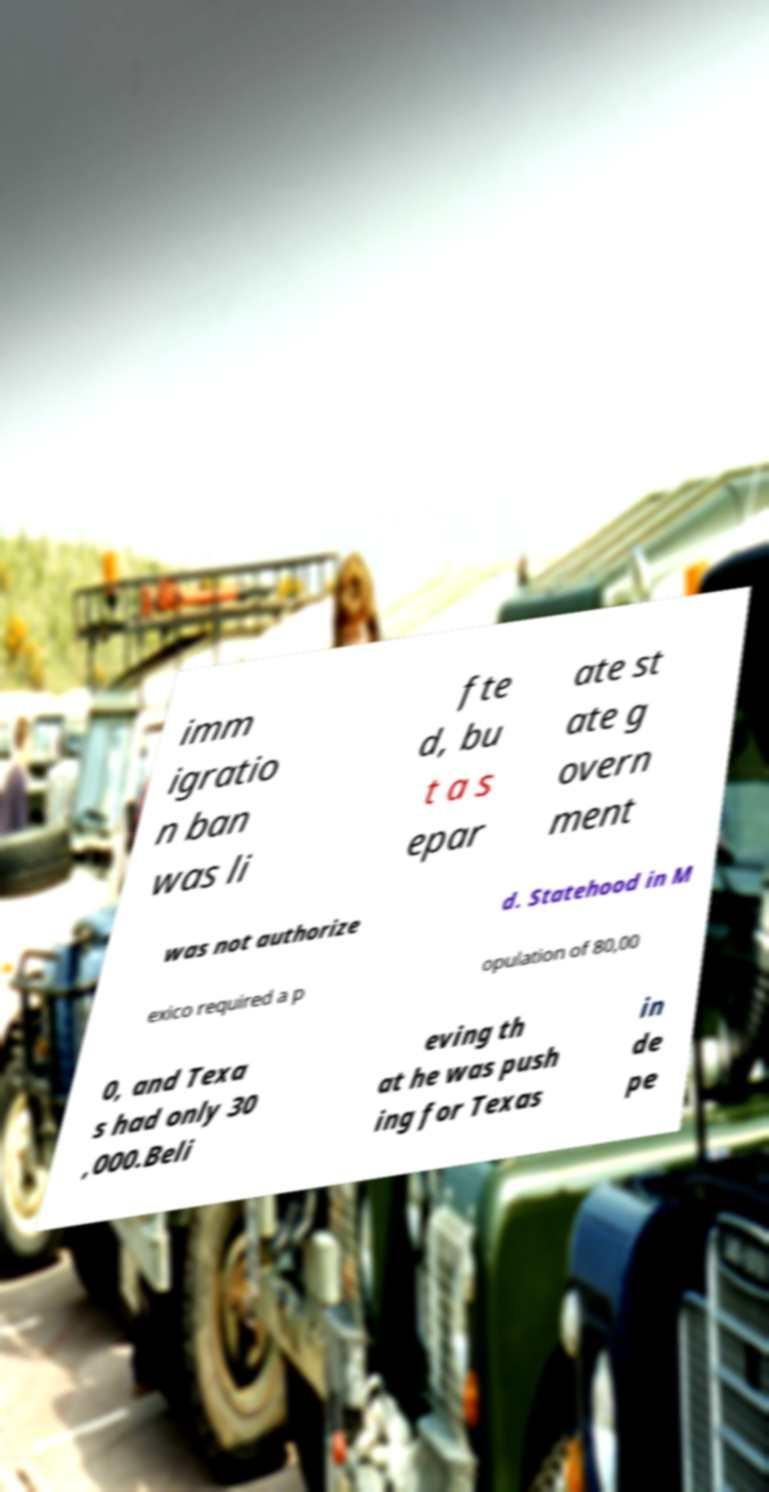There's text embedded in this image that I need extracted. Can you transcribe it verbatim? imm igratio n ban was li fte d, bu t a s epar ate st ate g overn ment was not authorize d. Statehood in M exico required a p opulation of 80,00 0, and Texa s had only 30 ,000.Beli eving th at he was push ing for Texas in de pe 